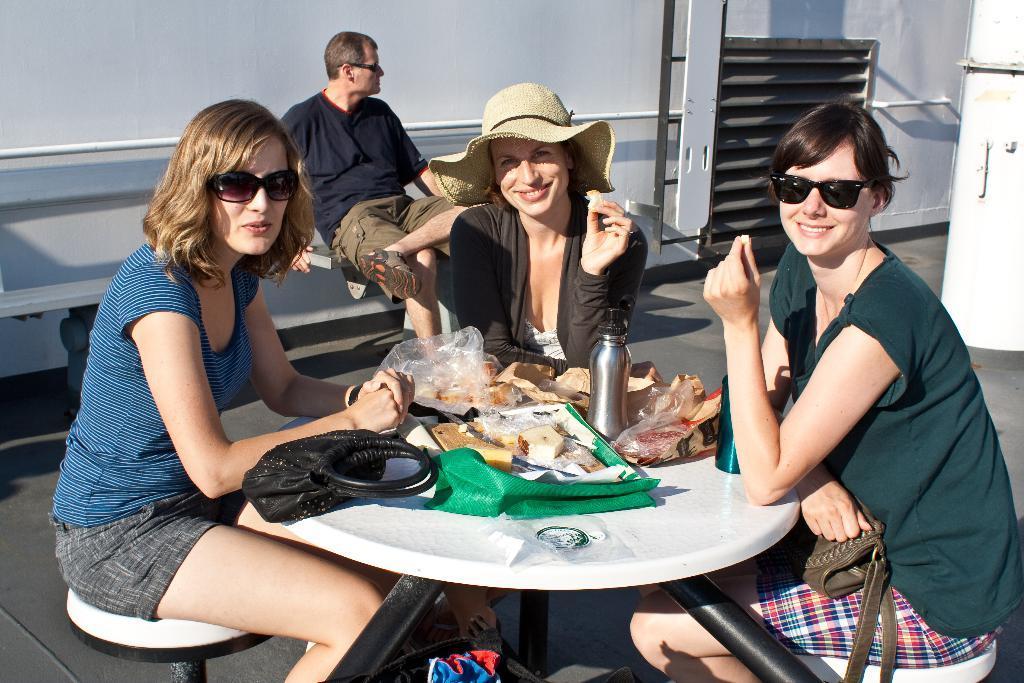In one or two sentences, can you explain what this image depicts? There are group of persons sitting on the chair and there are food items on the table and water bottles and a bag 